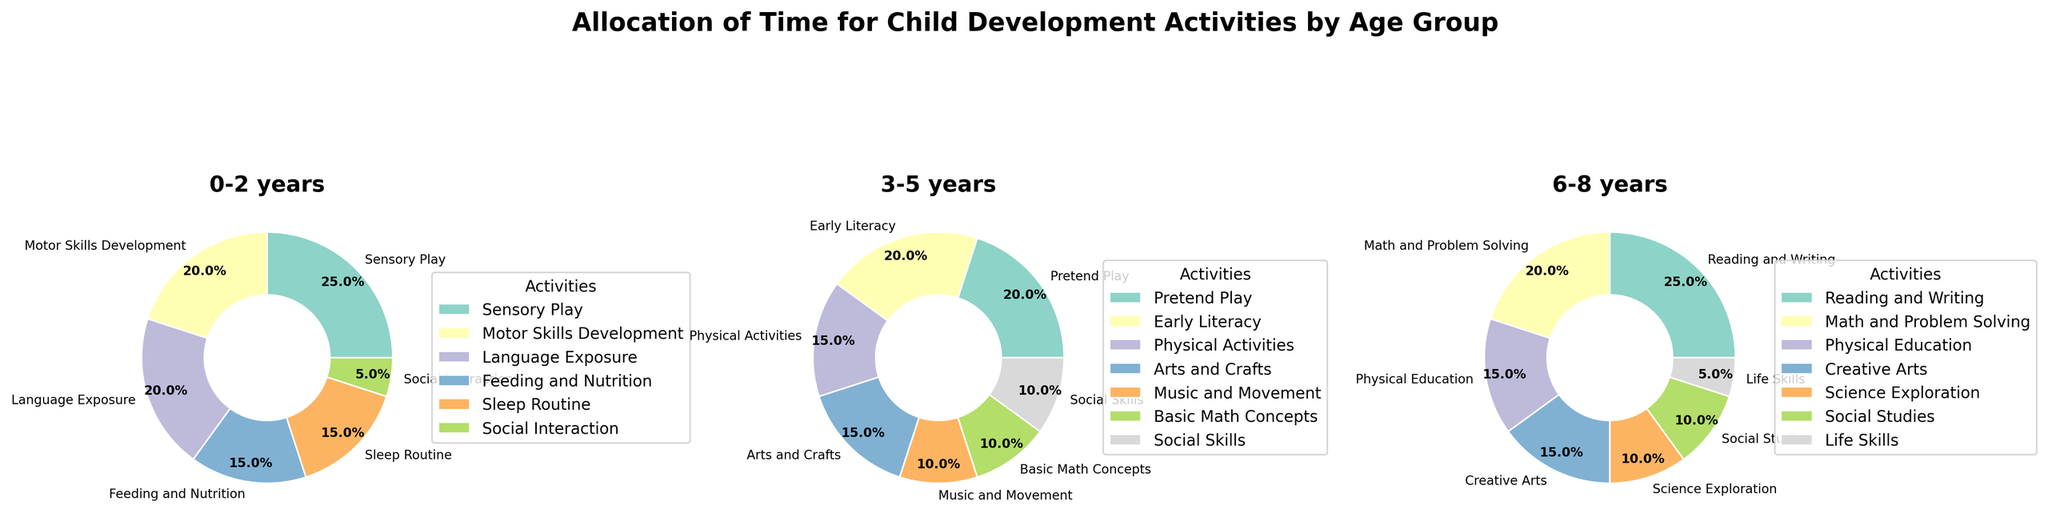Which age group allocates the highest percentage of time to a single activity? The 6-8 years age group allocates 25% of time to Reading and Writing, which is the highest percentage for a single activity among all age groups.
Answer: 6-8 years What is the combined percentage of time allocated to Language Exposure and Social Interaction for the 0-2 years age group? To get the combined percentage, add the percentage for Language Exposure (20%) and Social Interaction (5%). This equals 25%.
Answer: 25% How does the time spent on Physical Activities for the 3-5 years age group compare to Physical Education for the 6-8 years age group? Physical Activities in the 3-5 years age group accounts for 15%, while Physical Education in the 6-8 years age group also accounts for 15%. Both are the same.
Answer: Same Which age group dedicates the smallest percentage of time to Social Interaction/Skills? The 0-2 years age group spends 5% on Social Interaction, while the 3-5 years age group spends 10% on Social Skills. Therefore, the 0-2 years allocate the smallest percentage.
Answer: 0-2 years What can be inferred about the relative importance of creative activities (like Arts and Crafts) for the 3-5 years age group compared to the 6-8 years age group? For the 3-5 years age group, Arts and Crafts (15%) are given similar importance to Creative Arts for the 6-8 years age group (15%), showing equal emphasis.
Answer: Equal Sum up the percentages for Science Exploration and Life Skills in the 6-8 years age group and compare it to the percentage for Motor Skills Development in the 0-2 years age group. Science Exploration and Life Skills add up to 10% + 5% = 15% for the 6-8 years age group. Motor Skills Development is 20% for the 0-2 years age group. So, Motor Skills Development is higher by 5%.
Answer: Motor Skills Development is higher Is there any activity allocated 15% of time across more than one age group? Yes, Feeding and Nutrition (0-2 years), Physical Activities (3-5 years), and Physical Education (6-8 years) all allocate 15% of time.
Answer: Yes What is the average percentage allocated to Sleep Routine, Social Interaction, and Feeding and Nutrition for the 0-2 years age group? Add the percentages for Sleep Routine (15%), Social Interaction (5%), and Feeding and Nutrition (15%) to get 35%, then divide by the number of activities (3). The average is 35/3 = 11.67%.
Answer: 11.67% Compare the percentages allocated to Early Literacy and Pretend Play for the 3-5 years age group. Both Early Literacy and Pretend Play for the 3-5 years age group are allocated 20% each. They are equal.
Answer: Equal Within the 6-8 years age group, what is the difference in percentage allocation between Life Skills and the combined percentage for Social Studies and Science Exploration? Life Skills are allocated 5%, while Social Studies and Science Exploration combined are 10% + 10% = 20%. The difference is 20% - 5% = 15%.
Answer: 15% 